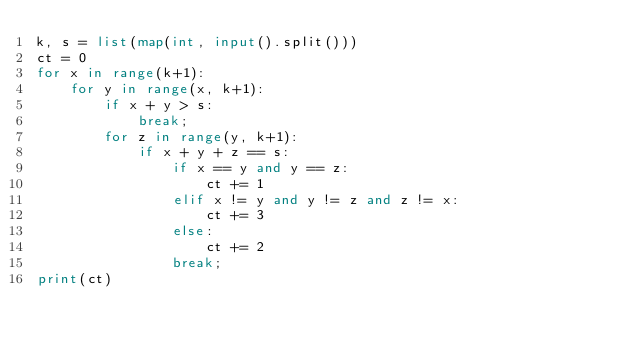<code> <loc_0><loc_0><loc_500><loc_500><_Python_>k, s = list(map(int, input().split()))
ct = 0
for x in range(k+1):
    for y in range(x, k+1):
        if x + y > s:
            break;
        for z in range(y, k+1):
            if x + y + z == s:
                if x == y and y == z:
                    ct += 1
                elif x != y and y != z and z != x:
                    ct += 3
                else:
                    ct += 2
                break;
print(ct)</code> 